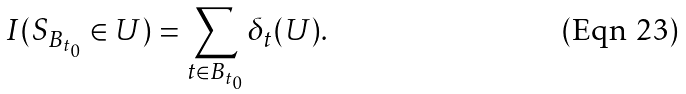<formula> <loc_0><loc_0><loc_500><loc_500>I ( S _ { B _ { t _ { 0 } } } \in U ) = \sum _ { t \in B _ { t _ { 0 } } } \delta _ { t } ( U ) .</formula> 